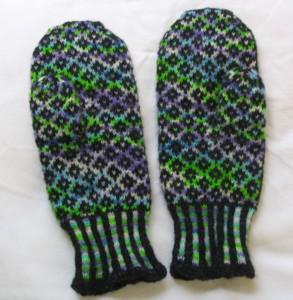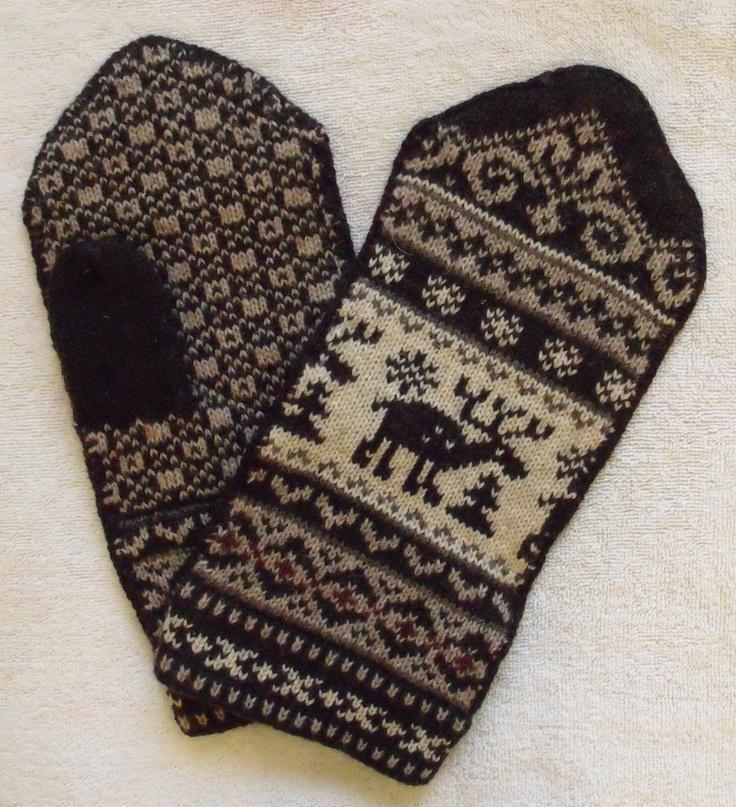The first image is the image on the left, the second image is the image on the right. Analyze the images presented: Is the assertion "The left and right image contains the same number of mittens with at least one set green." valid? Answer yes or no. Yes. The first image is the image on the left, the second image is the image on the right. Examine the images to the left and right. Is the description "Each image contains a pair of mittens, and one pair of mittens has an animal figure on the front-facing mitten." accurate? Answer yes or no. Yes. 